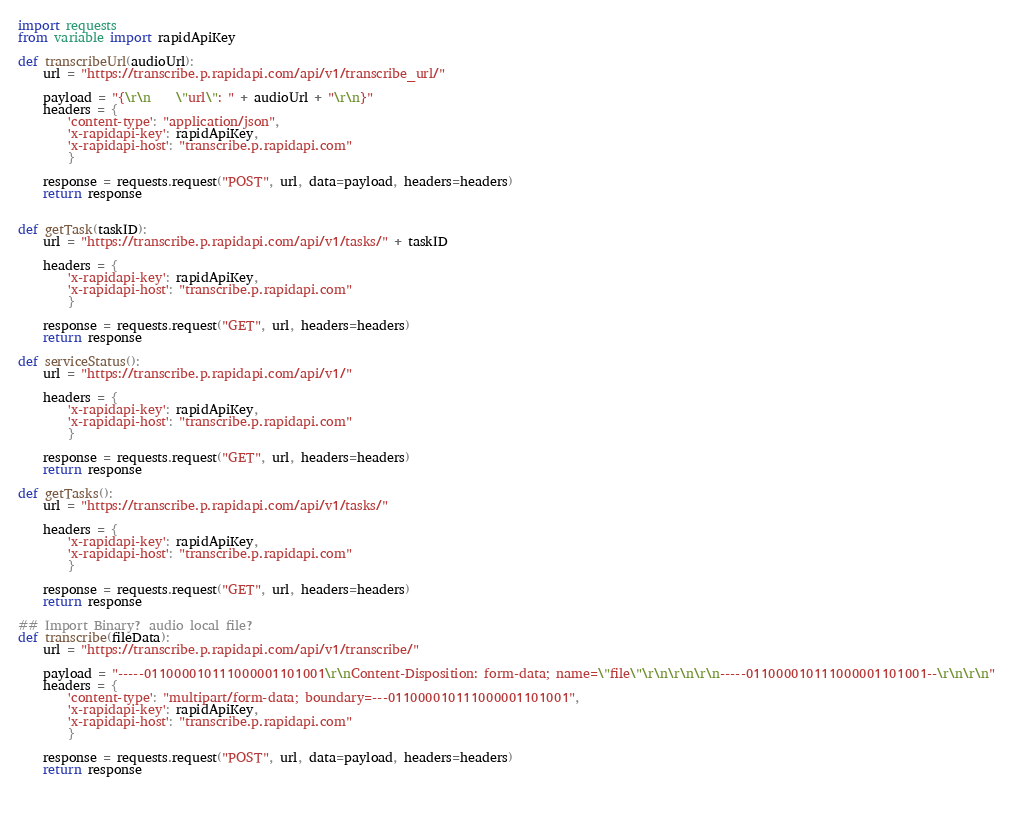<code> <loc_0><loc_0><loc_500><loc_500><_Python_>import requests
from variable import rapidApiKey

def transcribeUrl(audioUrl):
    url = "https://transcribe.p.rapidapi.com/api/v1/transcribe_url/"
    
    payload = "{\r\n    \"url\": " + audioUrl + "\r\n}"
    headers = {
        'content-type': "application/json",
        'x-rapidapi-key': rapidApiKey,
        'x-rapidapi-host': "transcribe.p.rapidapi.com"
        }

    response = requests.request("POST", url, data=payload, headers=headers)
    return response


def getTask(taskID):
    url = "https://transcribe.p.rapidapi.com/api/v1/tasks/" + taskID

    headers = {
        'x-rapidapi-key': rapidApiKey,
        'x-rapidapi-host': "transcribe.p.rapidapi.com"
        }

    response = requests.request("GET", url, headers=headers)
    return response

def serviceStatus():
    url = "https://transcribe.p.rapidapi.com/api/v1/"

    headers = {
        'x-rapidapi-key': rapidApiKey,
        'x-rapidapi-host': "transcribe.p.rapidapi.com"
        }

    response = requests.request("GET", url, headers=headers)
    return response

def getTasks():
    url = "https://transcribe.p.rapidapi.com/api/v1/tasks/"

    headers = {
        'x-rapidapi-key': rapidApiKey,
        'x-rapidapi-host': "transcribe.p.rapidapi.com"
        }

    response = requests.request("GET", url, headers=headers)
    return response
 
## Import Binary? audio local file?
def transcribe(fileData):
    url = "https://transcribe.p.rapidapi.com/api/v1/transcribe/"

    payload = "-----011000010111000001101001\r\nContent-Disposition: form-data; name=\"file\"\r\n\r\n\r\n-----011000010111000001101001--\r\n\r\n"
    headers = {
        'content-type': "multipart/form-data; boundary=---011000010111000001101001",
        'x-rapidapi-key': rapidApiKey,
        'x-rapidapi-host': "transcribe.p.rapidapi.com"
        }

    response = requests.request("POST", url, data=payload, headers=headers)
    return response

        
</code> 